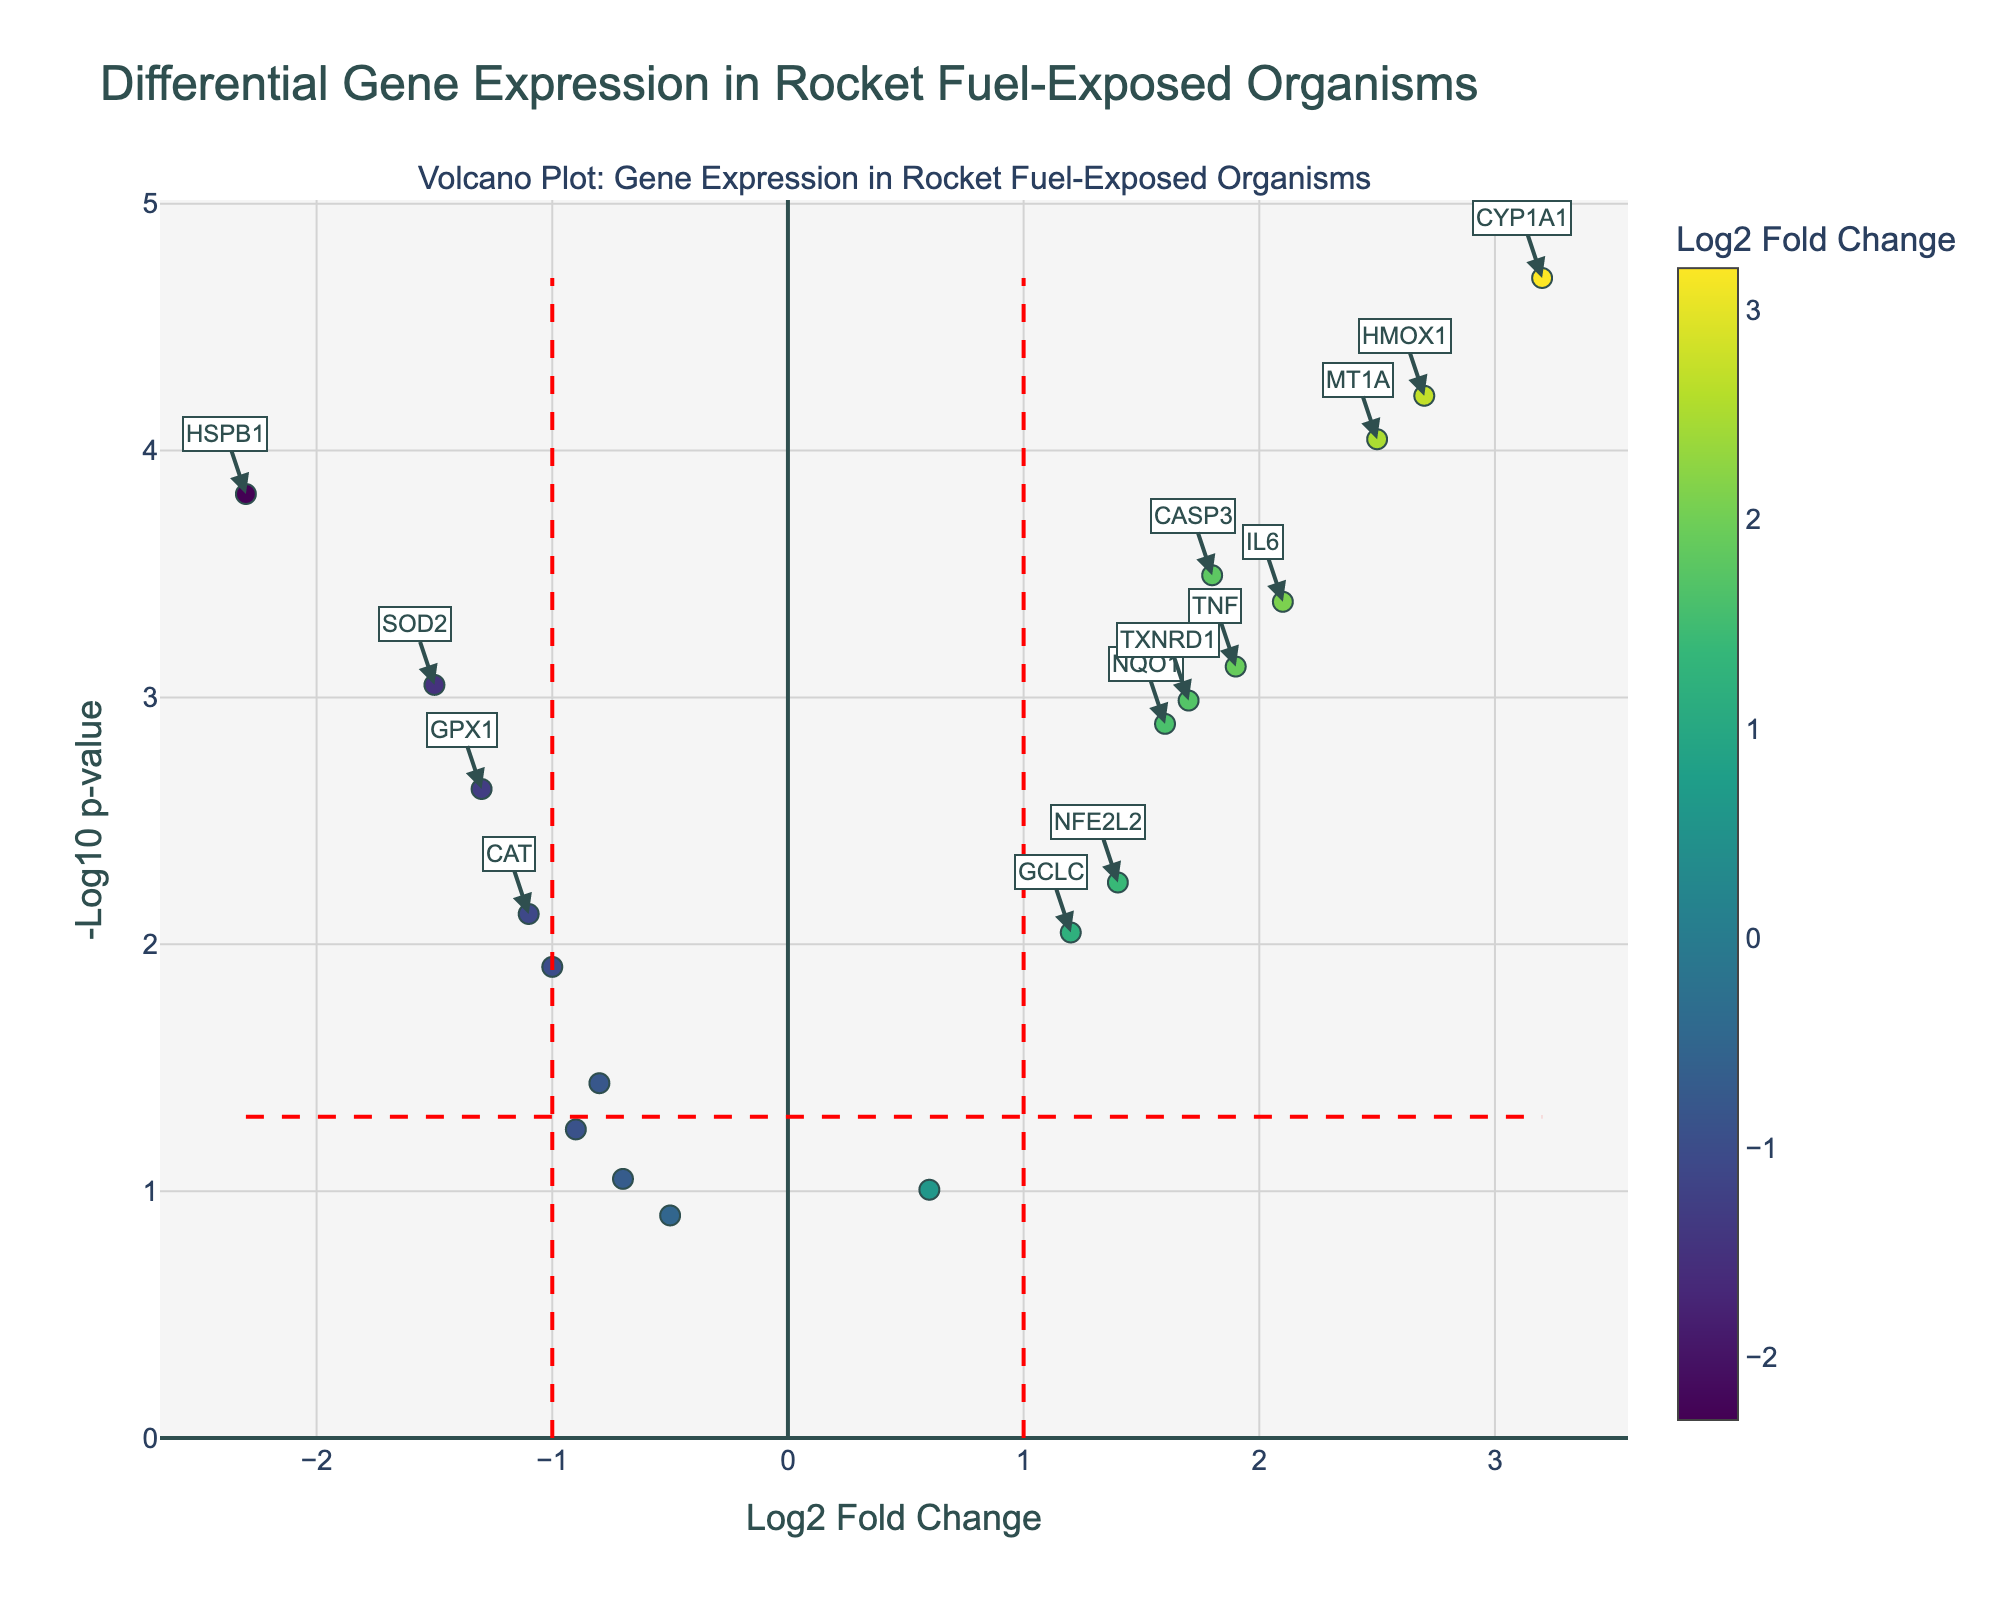Does the plot show overexpressed or underexpressed genes? The plot shows both overexpressed and underexpressed genes. Overexpressed genes have positive log2 fold change values (right side of the plot), while underexpressed genes have negative values (left side of the plot).
Answer: Both What does a high -log10 p-value indicate about a gene's expression? A high -log10 p-value indicates that the gene's expression change is statistically significant. The higher the value, the lower the p-value and the greater the significance.
Answer: Significant expression change How many genes are significantly differentially expressed (both upregulated and downregulated)? By identifying genes with absolute log2 fold change > 1 and p-value < 0.05, we count those that meet these criteria on the plot.
Answer: 11 Which gene has the highest log2 fold change and what is its significance? The gene with the highest log2 fold change (located furthest to the right on the x-axis) is CYP1A1 with a log2 fold change of 3.2 and a very low p-value (high -log10 p-value), indicating high significance.
Answer: CYP1A1 Which gene shows the most significant downregulation? The gene with the lowest log2 fold change (furthest to the left) that also has a high -log10 p-value (indicating significance) is HSPB1.
Answer: HSPB1 What are the axes titles on this plot? The x-axis shows the "Log2 Fold Change" and the y-axis shows the "-Log10 p-value".
Answer: Log2 Fold Change, -Log10 p-value How many genes fall below the p-value threshold but do not meet the fold change threshold? By examining the points below the -1 and 1 log2 fold change markers and above the -log10(p=0.05) line, and counting these data points, we find there are genes in this category.
Answer: 5 Can you name a gene that is upregulated and significantly expressed but not the highest upregulated? IL6 is upregulated with a log2 fold change of 2.1 and a p-value < 0.05, making it significant but not the most upregulated.
Answer: IL6 Which gene has the closest approximate log2 fold change value to 0. The gene EPHX1 has a log2 fold change closest to 0 (0.6) while also having a moderate -log10 p-value.
Answer: EPHX1 